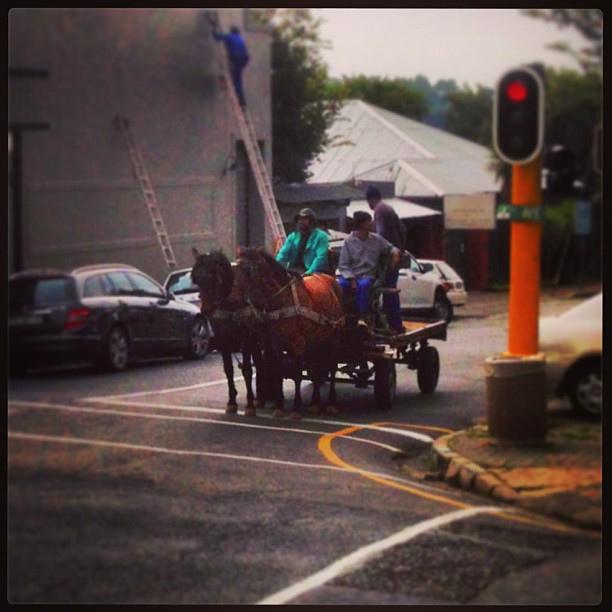Is the man on the ladder painting?
Be succinct. Yes. What color is the traffic signal?
Give a very brief answer. Red. How many horses are there?
Concise answer only. 2. 